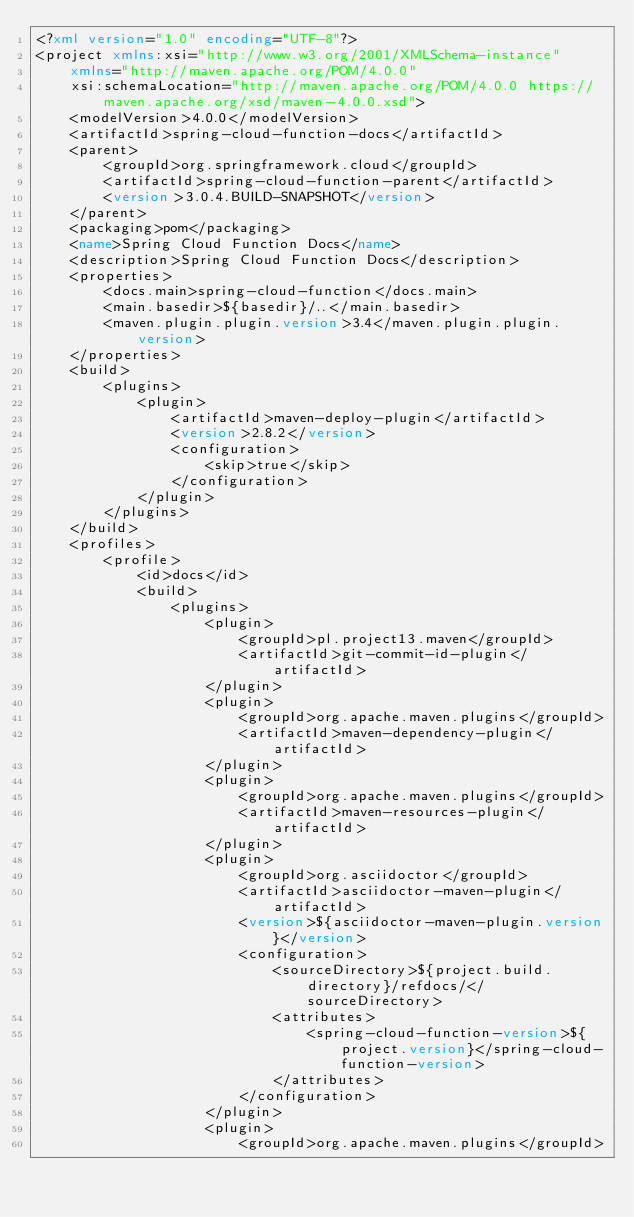Convert code to text. <code><loc_0><loc_0><loc_500><loc_500><_XML_><?xml version="1.0" encoding="UTF-8"?>
<project xmlns:xsi="http://www.w3.org/2001/XMLSchema-instance"
	xmlns="http://maven.apache.org/POM/4.0.0"
	xsi:schemaLocation="http://maven.apache.org/POM/4.0.0 https://maven.apache.org/xsd/maven-4.0.0.xsd">
	<modelVersion>4.0.0</modelVersion>
	<artifactId>spring-cloud-function-docs</artifactId>
	<parent>
		<groupId>org.springframework.cloud</groupId>
		<artifactId>spring-cloud-function-parent</artifactId>
		<version>3.0.4.BUILD-SNAPSHOT</version>
	</parent>
	<packaging>pom</packaging>
	<name>Spring Cloud Function Docs</name>
	<description>Spring Cloud Function Docs</description>
	<properties>
		<docs.main>spring-cloud-function</docs.main>
		<main.basedir>${basedir}/..</main.basedir>
		<maven.plugin.plugin.version>3.4</maven.plugin.plugin.version>
	</properties>
	<build>
		<plugins>
			<plugin>
				<artifactId>maven-deploy-plugin</artifactId>
				<version>2.8.2</version>
				<configuration>
					<skip>true</skip>
				</configuration>
			</plugin>
		</plugins>
	</build>
	<profiles>
		<profile>
			<id>docs</id>
			<build>
				<plugins>
					<plugin>
						<groupId>pl.project13.maven</groupId>
						<artifactId>git-commit-id-plugin</artifactId>
					</plugin>
					<plugin>
						<groupId>org.apache.maven.plugins</groupId>
						<artifactId>maven-dependency-plugin</artifactId>
					</plugin>
					<plugin>
						<groupId>org.apache.maven.plugins</groupId>
						<artifactId>maven-resources-plugin</artifactId>
					</plugin>
					<plugin>
						<groupId>org.asciidoctor</groupId>
						<artifactId>asciidoctor-maven-plugin</artifactId>
						<version>${asciidoctor-maven-plugin.version}</version>
						<configuration>
							<sourceDirectory>${project.build.directory}/refdocs/</sourceDirectory>
							<attributes>
								<spring-cloud-function-version>${project.version}</spring-cloud-function-version>
							</attributes>
						</configuration>
					</plugin>
					<plugin>
						<groupId>org.apache.maven.plugins</groupId></code> 